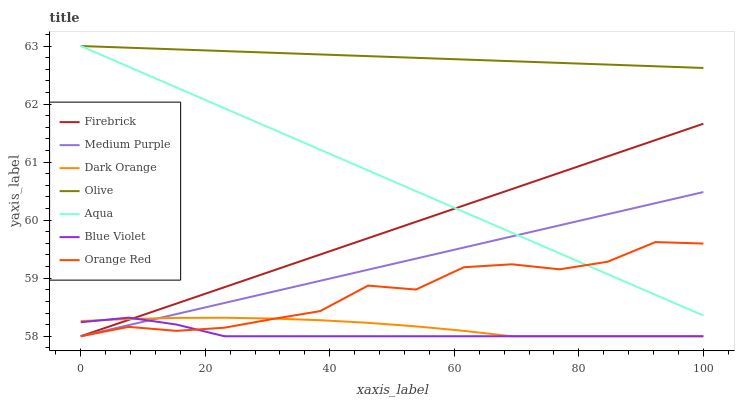Does Blue Violet have the minimum area under the curve?
Answer yes or no. Yes. Does Olive have the maximum area under the curve?
Answer yes or no. Yes. Does Firebrick have the minimum area under the curve?
Answer yes or no. No. Does Firebrick have the maximum area under the curve?
Answer yes or no. No. Is Olive the smoothest?
Answer yes or no. Yes. Is Orange Red the roughest?
Answer yes or no. Yes. Is Firebrick the smoothest?
Answer yes or no. No. Is Firebrick the roughest?
Answer yes or no. No. Does Dark Orange have the lowest value?
Answer yes or no. Yes. Does Aqua have the lowest value?
Answer yes or no. No. Does Olive have the highest value?
Answer yes or no. Yes. Does Firebrick have the highest value?
Answer yes or no. No. Is Orange Red less than Olive?
Answer yes or no. Yes. Is Olive greater than Dark Orange?
Answer yes or no. Yes. Does Firebrick intersect Orange Red?
Answer yes or no. Yes. Is Firebrick less than Orange Red?
Answer yes or no. No. Is Firebrick greater than Orange Red?
Answer yes or no. No. Does Orange Red intersect Olive?
Answer yes or no. No. 